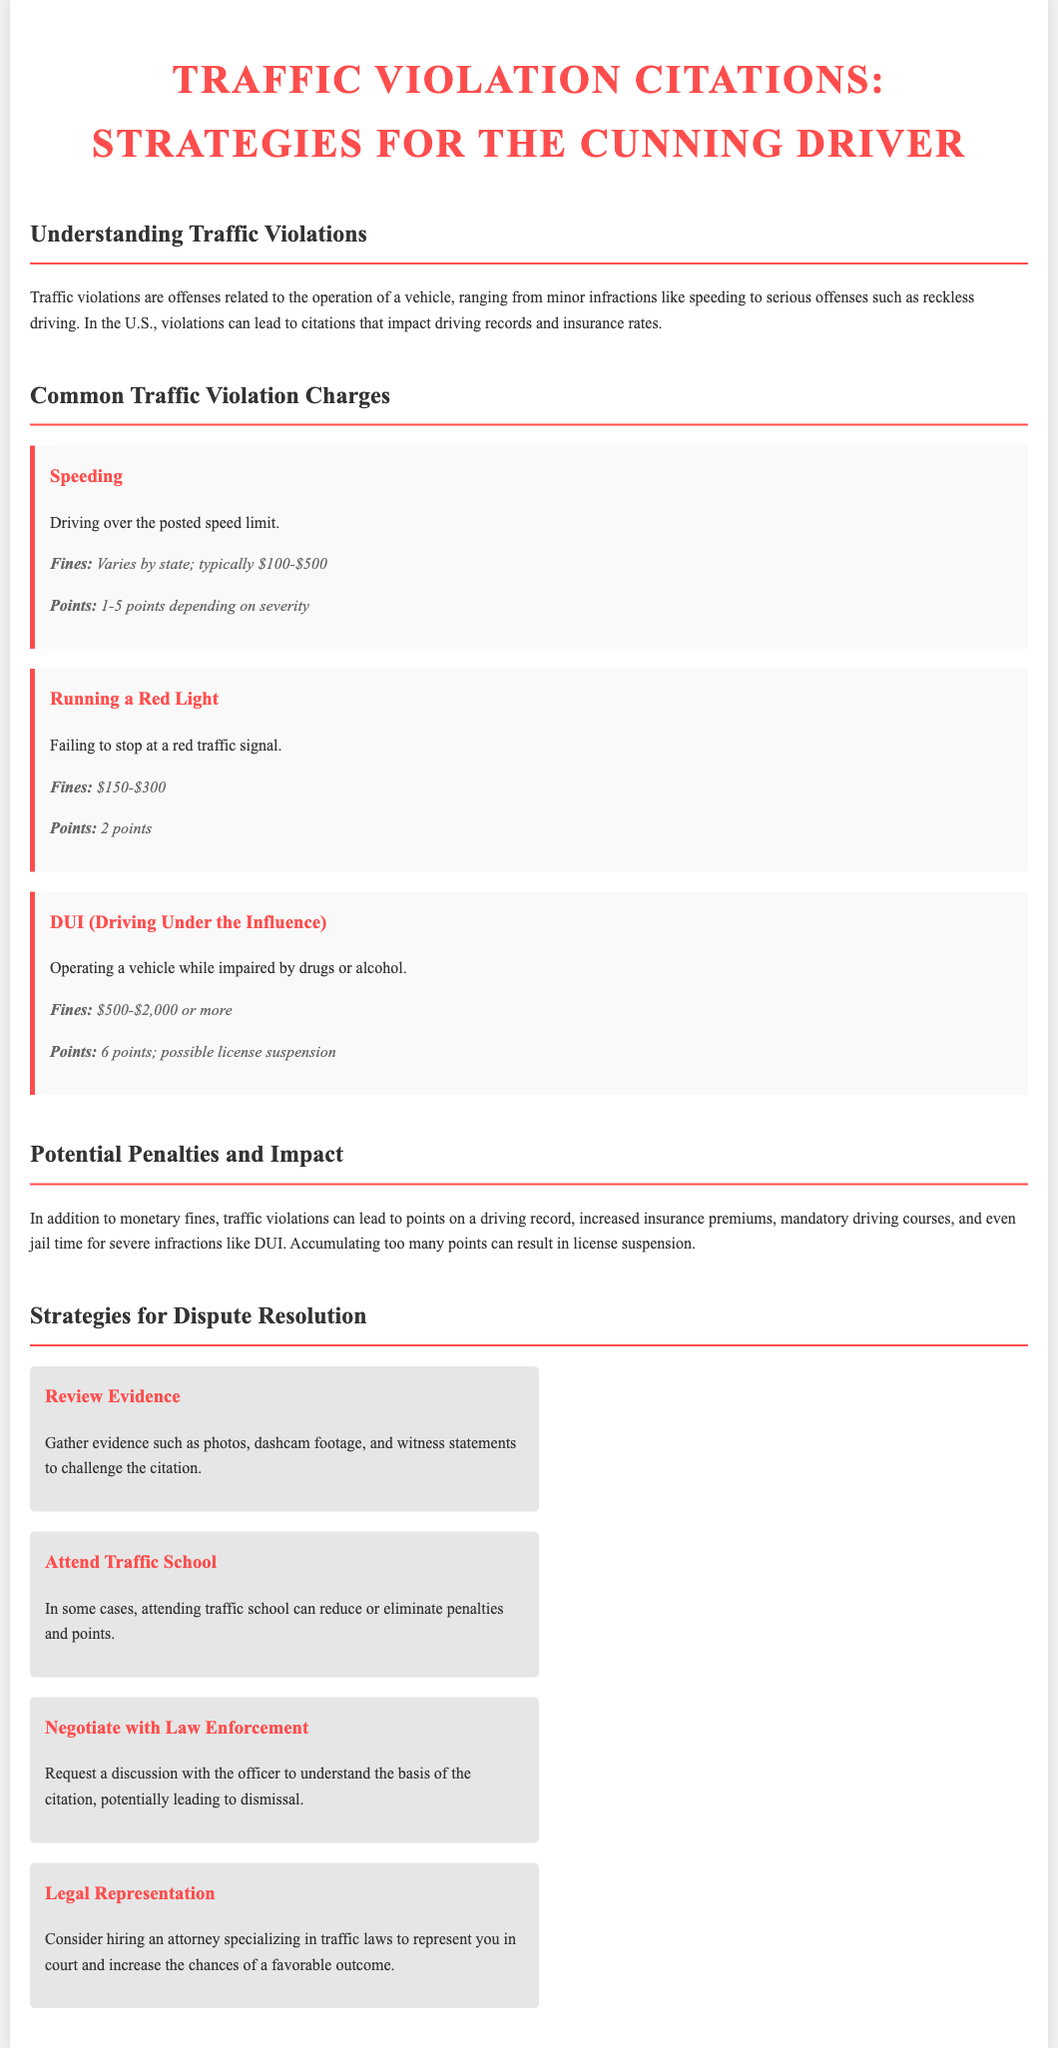What is the fine range for speeding? The fine range for speeding varies by state; typically $100-$500.
Answer: $100-$500 How many points are assigned for running a red light? The number of points assigned for running a red light is specified in the document.
Answer: 2 points What is the minimum fine for DUI? The document lists the minimum fine for DUI.
Answer: $500 What strategy can potentially reduce penalties? The document mentions strategies for dispute resolution, including one that could help with penalties.
Answer: Attend Traffic School What are the consequences of accumulating too many points? The document outlines a specific consequence when too many points are accumulated.
Answer: License suspension How many points can be associated with a DUI? The points associated with a DUI are detailed in the violations section of the document.
Answer: 6 points What is a recommended action to challenge a citation? The document provides a strategy that involves gathering certain kinds of evidence to challenge a citation.
Answer: Review Evidence What type of legal support is suggested for drivers? The document recommends a specific type of professional for legal support related to traffic citations.
Answer: Attorney specializing in traffic laws 